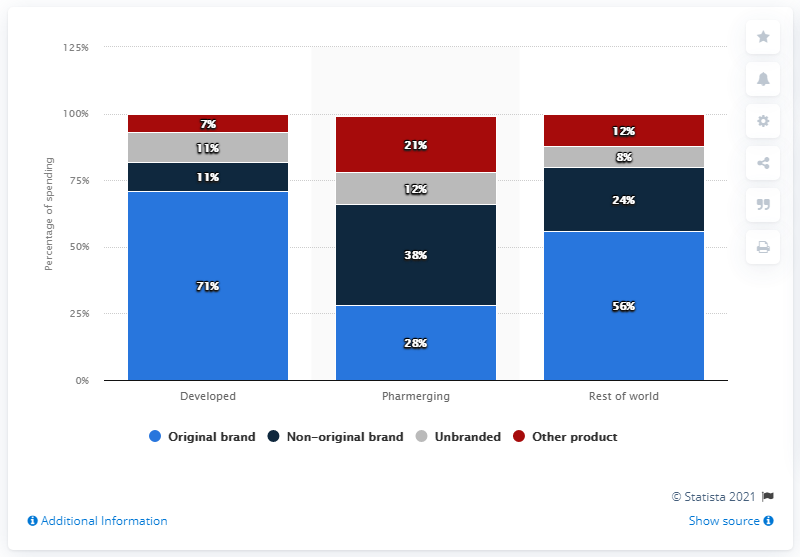Give some essential details in this illustration. By 2024, original brand drugs are expected to account for approximately 71% of total pharmaceutical spending in developed global markets. 